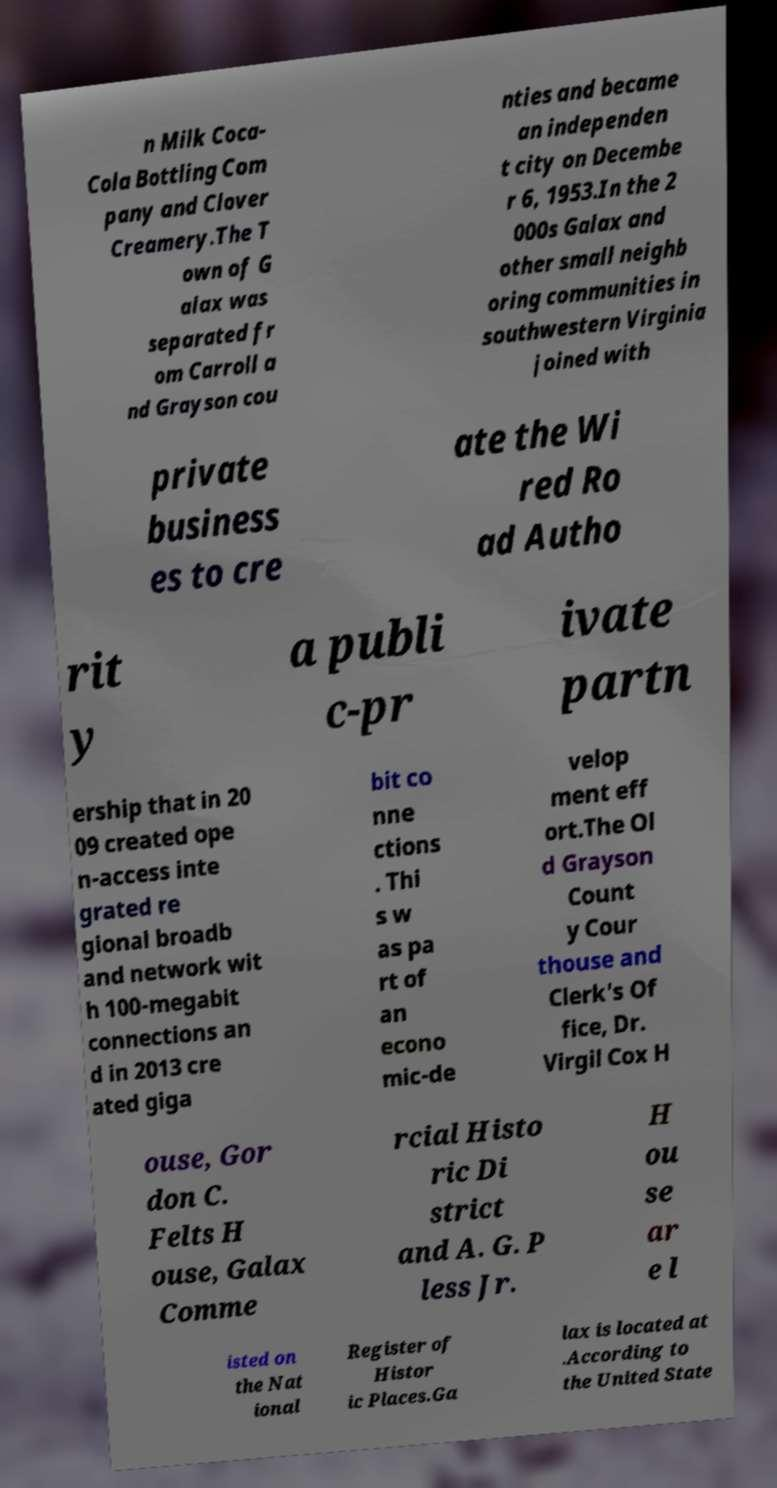I need the written content from this picture converted into text. Can you do that? n Milk Coca- Cola Bottling Com pany and Clover Creamery.The T own of G alax was separated fr om Carroll a nd Grayson cou nties and became an independen t city on Decembe r 6, 1953.In the 2 000s Galax and other small neighb oring communities in southwestern Virginia joined with private business es to cre ate the Wi red Ro ad Autho rit y a publi c-pr ivate partn ership that in 20 09 created ope n-access inte grated re gional broadb and network wit h 100-megabit connections an d in 2013 cre ated giga bit co nne ctions . Thi s w as pa rt of an econo mic-de velop ment eff ort.The Ol d Grayson Count y Cour thouse and Clerk's Of fice, Dr. Virgil Cox H ouse, Gor don C. Felts H ouse, Galax Comme rcial Histo ric Di strict and A. G. P less Jr. H ou se ar e l isted on the Nat ional Register of Histor ic Places.Ga lax is located at .According to the United State 